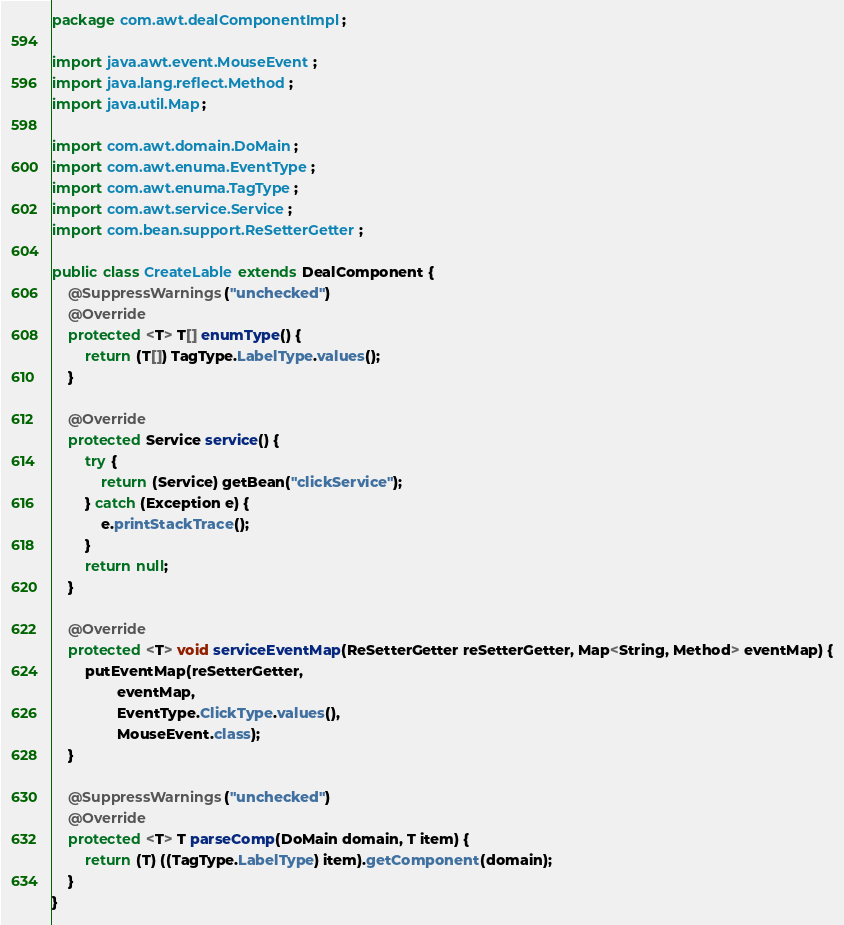Convert code to text. <code><loc_0><loc_0><loc_500><loc_500><_Java_>package com.awt.dealComponentImpl;

import java.awt.event.MouseEvent;
import java.lang.reflect.Method;
import java.util.Map;

import com.awt.domain.DoMain;
import com.awt.enuma.EventType;
import com.awt.enuma.TagType;
import com.awt.service.Service;
import com.bean.support.ReSetterGetter;

public class CreateLable extends DealComponent {
	@SuppressWarnings("unchecked")
	@Override
	protected <T> T[] enumType() {
		return (T[]) TagType.LabelType.values();
	}

	@Override
	protected Service service() {
		try {
			return (Service) getBean("clickService");
		} catch (Exception e) {
			e.printStackTrace();
		}
		return null;
	}

	@Override
	protected <T> void serviceEventMap(ReSetterGetter reSetterGetter, Map<String, Method> eventMap) {
		putEventMap(reSetterGetter, 
				eventMap, 
				EventType.ClickType.values(), 
				MouseEvent.class);
	}

	@SuppressWarnings("unchecked")
	@Override
	protected <T> T parseComp(DoMain domain, T item) {
		return (T) ((TagType.LabelType) item).getComponent(domain);
	}
}
</code> 